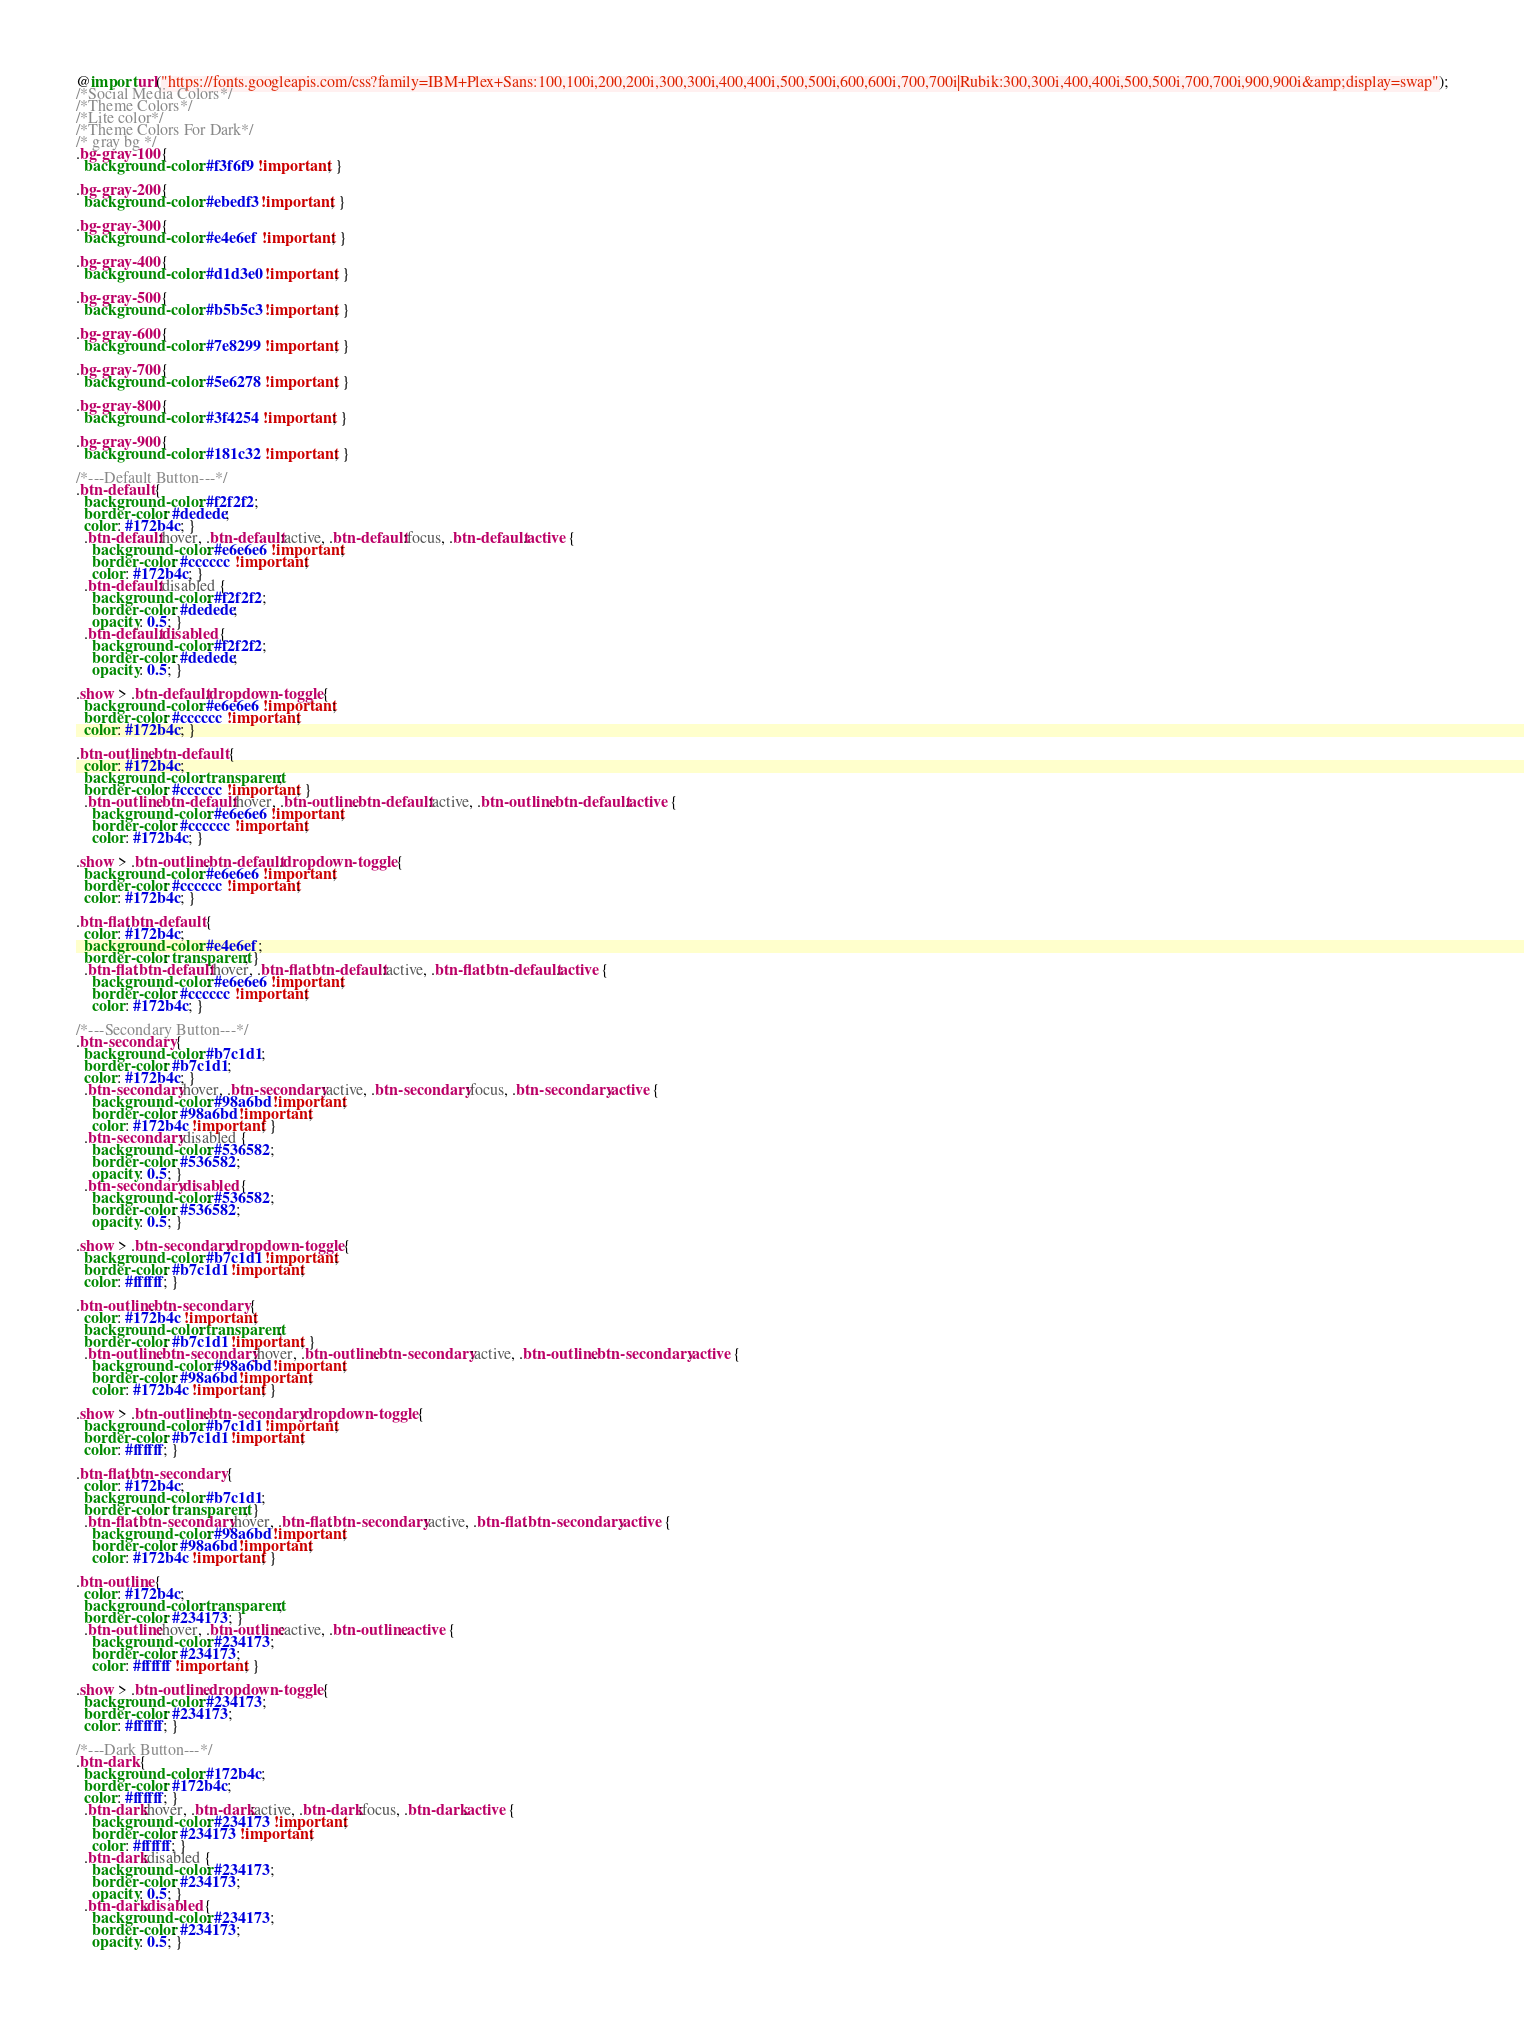Convert code to text. <code><loc_0><loc_0><loc_500><loc_500><_CSS_>@import url("https://fonts.googleapis.com/css?family=IBM+Plex+Sans:100,100i,200,200i,300,300i,400,400i,500,500i,600,600i,700,700i|Rubik:300,300i,400,400i,500,500i,700,700i,900,900i&amp;display=swap");
/*Social Media Colors*/
/*Theme Colors*/
/*Lite color*/
/*Theme Colors For Dark*/
/* gray bg */
.bg-gray-100 {
  background-color: #f3f6f9 !important; }

.bg-gray-200 {
  background-color: #ebedf3 !important; }

.bg-gray-300 {
  background-color: #e4e6ef !important; }

.bg-gray-400 {
  background-color: #d1d3e0 !important; }

.bg-gray-500 {
  background-color: #b5b5c3 !important; }

.bg-gray-600 {
  background-color: #7e8299 !important; }

.bg-gray-700 {
  background-color: #5e6278 !important; }

.bg-gray-800 {
  background-color: #3f4254 !important; }

.bg-gray-900 {
  background-color: #181c32 !important; }

/*---Default Button---*/
.btn-default {
  background-color: #f2f2f2;
  border-color: #dedede;
  color: #172b4c; }
  .btn-default:hover, .btn-default:active, .btn-default:focus, .btn-default.active {
    background-color: #e6e6e6 !important;
    border-color: #cccccc !important;
    color: #172b4c; }
  .btn-default:disabled {
    background-color: #f2f2f2;
    border-color: #dedede;
    opacity: 0.5; }
  .btn-default.disabled {
    background-color: #f2f2f2;
    border-color: #dedede;
    opacity: 0.5; }

.show > .btn-default.dropdown-toggle {
  background-color: #e6e6e6 !important;
  border-color: #cccccc !important;
  color: #172b4c; }

.btn-outline.btn-default {
  color: #172b4c;
  background-color: transparent;
  border-color: #cccccc !important; }
  .btn-outline.btn-default:hover, .btn-outline.btn-default:active, .btn-outline.btn-default.active {
    background-color: #e6e6e6 !important;
    border-color: #cccccc !important;
    color: #172b4c; }

.show > .btn-outline.btn-default.dropdown-toggle {
  background-color: #e6e6e6 !important;
  border-color: #cccccc !important;
  color: #172b4c; }

.btn-flat.btn-default {
  color: #172b4c;
  background-color: #e4e6ef;
  border-color: transparent; }
  .btn-flat.btn-default:hover, .btn-flat.btn-default:active, .btn-flat.btn-default.active {
    background-color: #e6e6e6 !important;
    border-color: #cccccc !important;
    color: #172b4c; }

/*---Secondary Button---*/
.btn-secondary {
  background-color: #b7c1d1;
  border-color: #b7c1d1;
  color: #172b4c; }
  .btn-secondary:hover, .btn-secondary:active, .btn-secondary:focus, .btn-secondary.active {
    background-color: #98a6bd !important;
    border-color: #98a6bd !important;
    color: #172b4c !important; }
  .btn-secondary:disabled {
    background-color: #536582;
    border-color: #536582;
    opacity: 0.5; }
  .btn-secondary.disabled {
    background-color: #536582;
    border-color: #536582;
    opacity: 0.5; }

.show > .btn-secondary.dropdown-toggle {
  background-color: #b7c1d1 !important;
  border-color: #b7c1d1 !important;
  color: #ffffff; }

.btn-outline.btn-secondary {
  color: #172b4c !important;
  background-color: transparent;
  border-color: #b7c1d1 !important; }
  .btn-outline.btn-secondary:hover, .btn-outline.btn-secondary:active, .btn-outline.btn-secondary.active {
    background-color: #98a6bd !important;
    border-color: #98a6bd !important;
    color: #172b4c !important; }

.show > .btn-outline.btn-secondary.dropdown-toggle {
  background-color: #b7c1d1 !important;
  border-color: #b7c1d1 !important;
  color: #ffffff; }

.btn-flat.btn-secondary {
  color: #172b4c;
  background-color: #b7c1d1;
  border-color: transparent; }
  .btn-flat.btn-secondary:hover, .btn-flat.btn-secondary:active, .btn-flat.btn-secondary.active {
    background-color: #98a6bd !important;
    border-color: #98a6bd !important;
    color: #172b4c !important; }

.btn-outline {
  color: #172b4c;
  background-color: transparent;
  border-color: #234173; }
  .btn-outline:hover, .btn-outline:active, .btn-outline.active {
    background-color: #234173;
    border-color: #234173;
    color: #ffffff !important; }

.show > .btn-outline.dropdown-toggle {
  background-color: #234173;
  border-color: #234173;
  color: #ffffff; }

/*---Dark Button---*/
.btn-dark {
  background-color: #172b4c;
  border-color: #172b4c;
  color: #ffffff; }
  .btn-dark:hover, .btn-dark:active, .btn-dark:focus, .btn-dark.active {
    background-color: #234173 !important;
    border-color: #234173 !important;
    color: #ffffff; }
  .btn-dark:disabled {
    background-color: #234173;
    border-color: #234173;
    opacity: 0.5; }
  .btn-dark.disabled {
    background-color: #234173;
    border-color: #234173;
    opacity: 0.5; }
</code> 